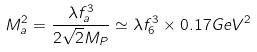<formula> <loc_0><loc_0><loc_500><loc_500>M _ { a } ^ { 2 } = \frac { \lambda f _ { a } ^ { 3 } } { 2 \sqrt { 2 } M _ { P } } \simeq \lambda f _ { 6 } ^ { 3 } \times 0 . 1 7 { G e V } ^ { 2 }</formula> 